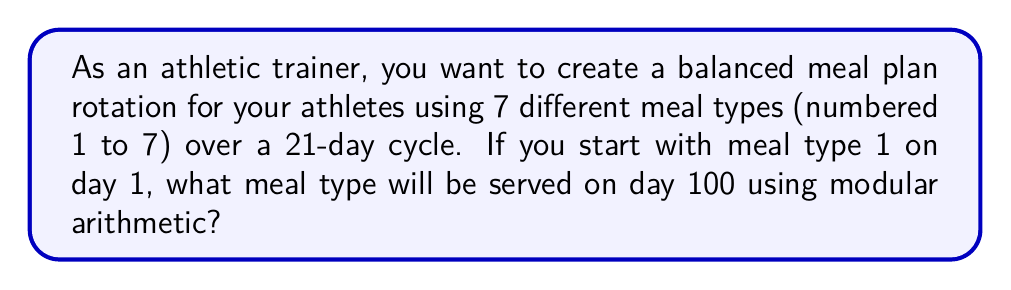What is the answer to this math problem? Let's approach this step-by-step using modular arithmetic:

1) First, we need to understand that the meal types will repeat every 7 days within the 21-day cycle. This means we can use modulo 7 for our calculations.

2) To find the meal type on day 100, we need to determine what day of the cycle day 100 corresponds to:

   $100 \equiv x \pmod{21}$

3) We can solve this by dividing 100 by 21:

   $100 = 21 \cdot 4 + 16$

   So, $100 \equiv 16 \pmod{21}$

4) This means day 100 is equivalent to day 16 in our 21-day cycle.

5) Now, we need to determine which meal type corresponds to day 16. We can use modulo 7 for this:

   $16 \equiv y \pmod{7}$

6) Dividing 16 by 7:

   $16 = 7 \cdot 2 + 2$

   So, $16 \equiv 2 \pmod{7}$

7) Since we started with meal type 1 on day 1, meal type 2 will be served on day 2, meal type 3 on day 3, and so on.

8) Therefore, meal type 2 will be served on day 16, which is equivalent to day 100.
Answer: 2 